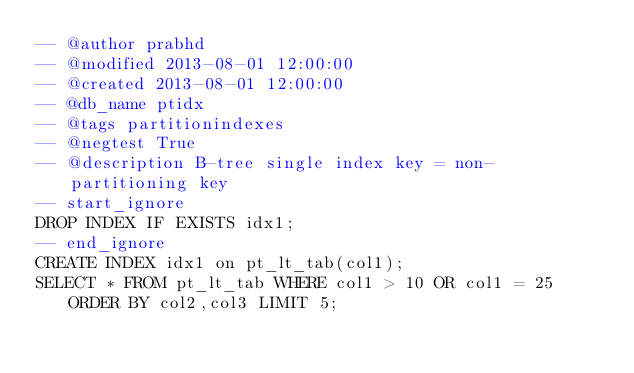Convert code to text. <code><loc_0><loc_0><loc_500><loc_500><_SQL_>-- @author prabhd
-- @modified 2013-08-01 12:00:00
-- @created 2013-08-01 12:00:00
-- @db_name ptidx
-- @tags partitionindexes
-- @negtest True
-- @description B-tree single index key = non-partitioning key
-- start_ignore
DROP INDEX IF EXISTS idx1;
-- end_ignore
CREATE INDEX idx1 on pt_lt_tab(col1);
SELECT * FROM pt_lt_tab WHERE col1 > 10 OR col1 = 25 ORDER BY col2,col3 LIMIT 5;
</code> 